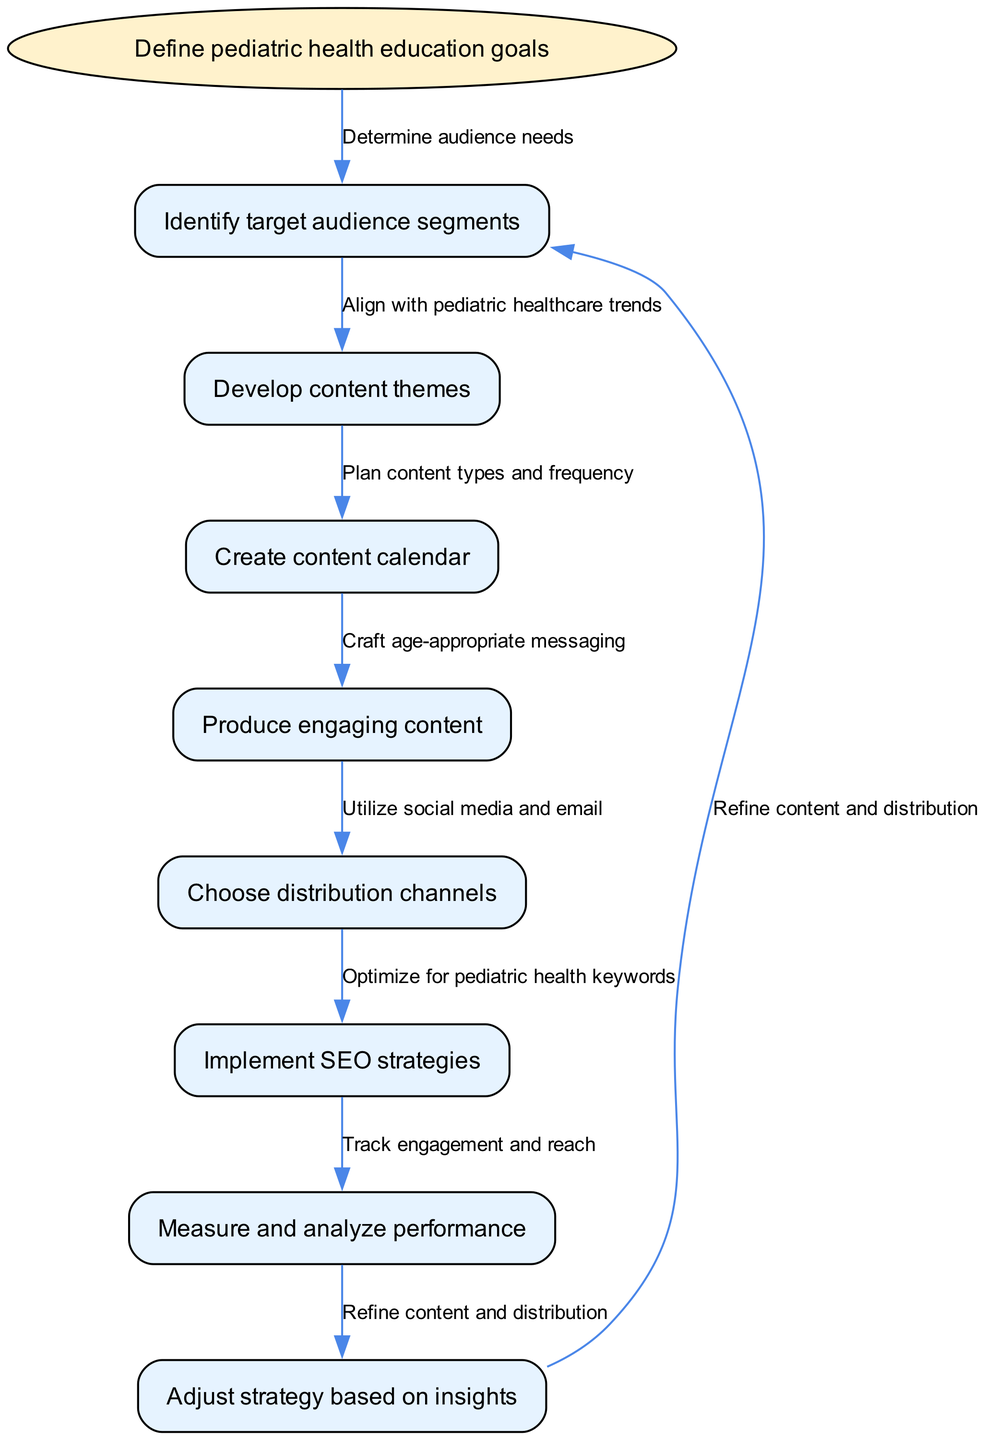What is the first step in the content marketing plan? The diagram shows that the first step is labeled as "Define pediatric health education goals", which is the starting node in the flow chart.
Answer: Define pediatric health education goals How many nodes are present in the diagram? By counting each listed item in the nodes section of the diagram, there are eight nodes, including the start node and all subsequent steps.
Answer: 8 What follows the "Identify target audience segments" step? The diagram indicates that the next step after "Identify target audience segments" is "Develop content themes", which is connected directly in the flow.
Answer: Develop content themes Which distribution channel is suggested in the diagram? The flow chart mentions "Utilize social media and email" as a suggested distribution channel, which is connected to the relevant content creation step.
Answer: Utilize social media and email What is the last node in the flow chart? The final step in the diagram is labeled as "Adjust strategy based on insights", which indicates it concludes the instruction flow cycle and loops back to the first step.
Answer: Adjust strategy based on insights After "Produce engaging content", what is the next node in the instruction? The next node after "Produce engaging content" is "Choose distribution channels", as seen by following the directed edge that connects these two steps in the flow.
Answer: Choose distribution channels What is the relation between "Measure and analyze performance" and "Adjust strategy based on insights"? The diagram shows that "Measure and analyze performance" leads directly to "Adjust strategy based on insights", indicating that performance analysis informs strategy adjustment.
Answer: Adjust strategy based on insights What is the flow direction of the diagram? The flow direction is top-to-bottom, starting from the initial goal definition and proceeding through each step sequentially to the final adjustment step, creating a clear actionable pathway.
Answer: Top-to-bottom 